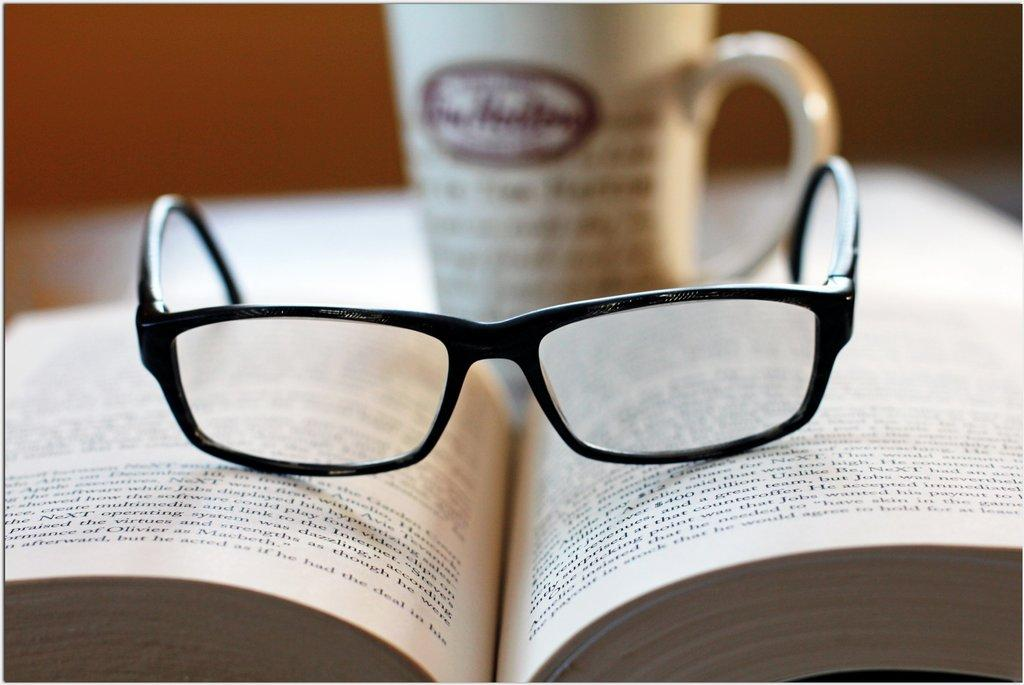What objects are placed on top of a book in the image? There are glasses on a book in the image. What other type of container is visible in the image? There is a cup in the image. What idea is being conveyed by the box in the image? There is no box present in the image, so no idea can be conveyed by a box. 